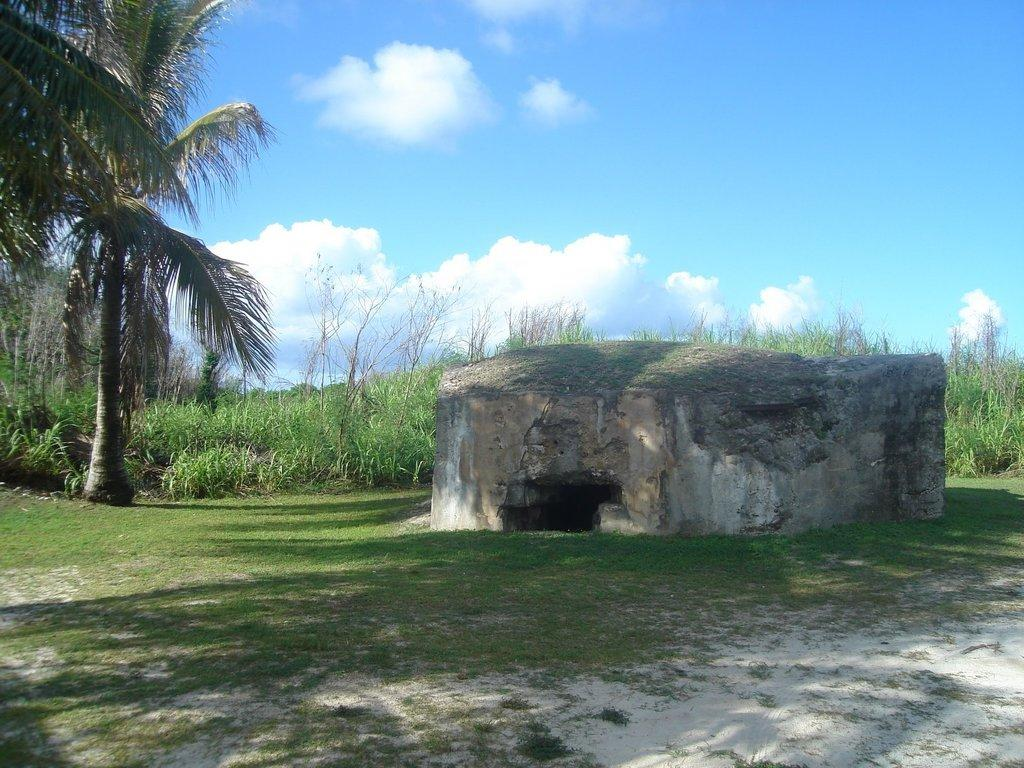What is the main feature in the center of the image? There is a small cave in the center of the image. What is the cave situated on? The cave is on the grass. What can be seen in the background of the image? There are plants, trees, and the sky visible in the background of the image. What is the condition of the sky in the image? Clouds are present in the sky. What type of patch is being used to fix the pail in the image? There is no pail or patch present in the image. What kind of insurance policy is being discussed by the trees in the background? There is no discussion of insurance policies in the image, and the trees are not capable of discussing anything. 